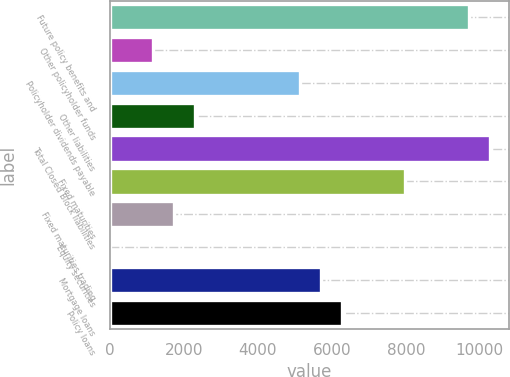Convert chart to OTSL. <chart><loc_0><loc_0><loc_500><loc_500><bar_chart><fcel>Future policy benefits and<fcel>Other policyholder funds<fcel>Policyholder dividends payable<fcel>Other liabilities<fcel>Total Closed Block liabilities<fcel>Fixed maturities<fcel>Fixed maturities trading<fcel>Equity securities<fcel>Mortgage loans<fcel>Policy loans<nl><fcel>9698.93<fcel>1155.08<fcel>5142.21<fcel>2294.26<fcel>10268.5<fcel>7990.16<fcel>1724.67<fcel>15.9<fcel>5711.8<fcel>6281.39<nl></chart> 